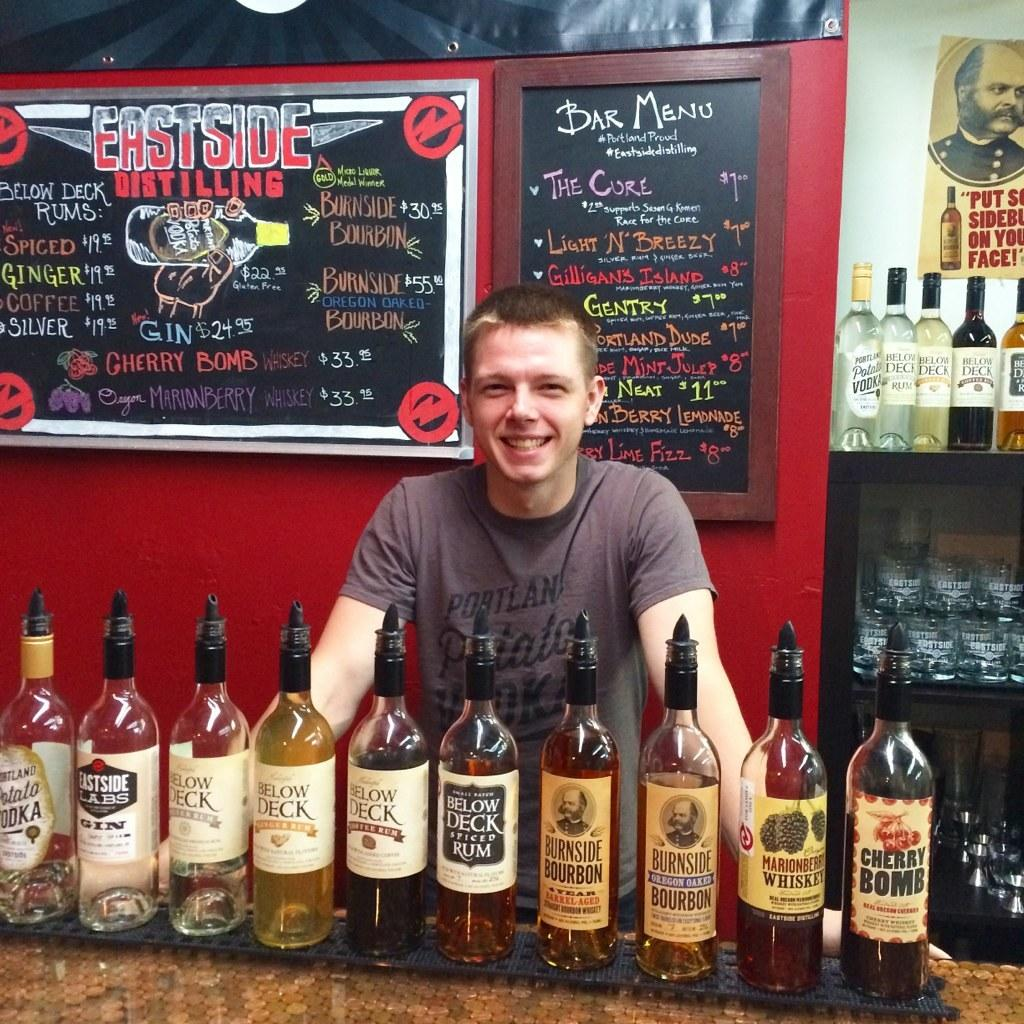<image>
Provide a brief description of the given image. A man stands in front of an Eastside Distilling sign with several liquor bottles lined up on the bar in front of him. 